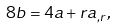<formula> <loc_0><loc_0><loc_500><loc_500>8 b = 4 a + r a _ { , r } ,</formula> 